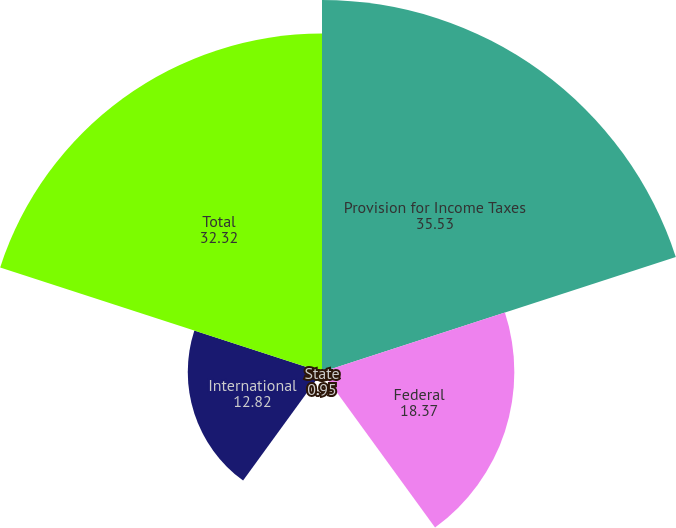Convert chart to OTSL. <chart><loc_0><loc_0><loc_500><loc_500><pie_chart><fcel>Provision for Income Taxes<fcel>Federal<fcel>State<fcel>International<fcel>Total<nl><fcel>35.53%<fcel>18.37%<fcel>0.95%<fcel>12.82%<fcel>32.32%<nl></chart> 